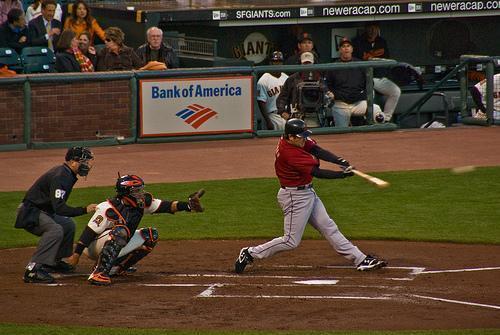How many people are crouching?
Give a very brief answer. 2. How many men are on the field?
Give a very brief answer. 3. 